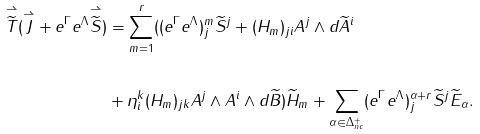<formula> <loc_0><loc_0><loc_500><loc_500>\overset { \rightharpoonup } { \widetilde { T } } ( \overset { \rightharpoonup } { J } + e ^ { \Gamma } e ^ { \Lambda } \overset { \rightharpoonup } { \widetilde { S } } ) & = \overset { r } { \underset { m = 1 } { \sum } } ( ( e ^ { \Gamma } e ^ { \Lambda } ) _ { j } ^ { m } \widetilde { S } ^ { j } + ( H _ { m } ) _ { j i } A ^ { j } \wedge d \widetilde { A } ^ { i } \\ \\ & + \eta _ { i } ^ { k } ( H _ { m } ) _ { j k } A ^ { j } \wedge A ^ { i } \wedge d \widetilde { B } ) \widetilde { H } _ { m } + \underset { \alpha \in \Delta _ { n c } ^ { + } } { \sum } ( e ^ { \Gamma } e ^ { \Lambda } ) _ { j } ^ { \alpha + r } \widetilde { S } ^ { j } \widetilde { E } _ { \alpha } .</formula> 